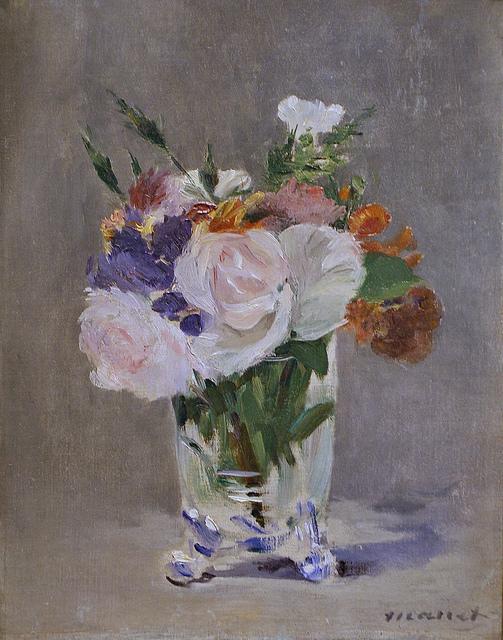What is this a painting of?
Quick response, please. Flowers. What is the color of the flowers?
Short answer required. White,blue,orange,red,purple. Is that a real vase?
Be succinct. No. 